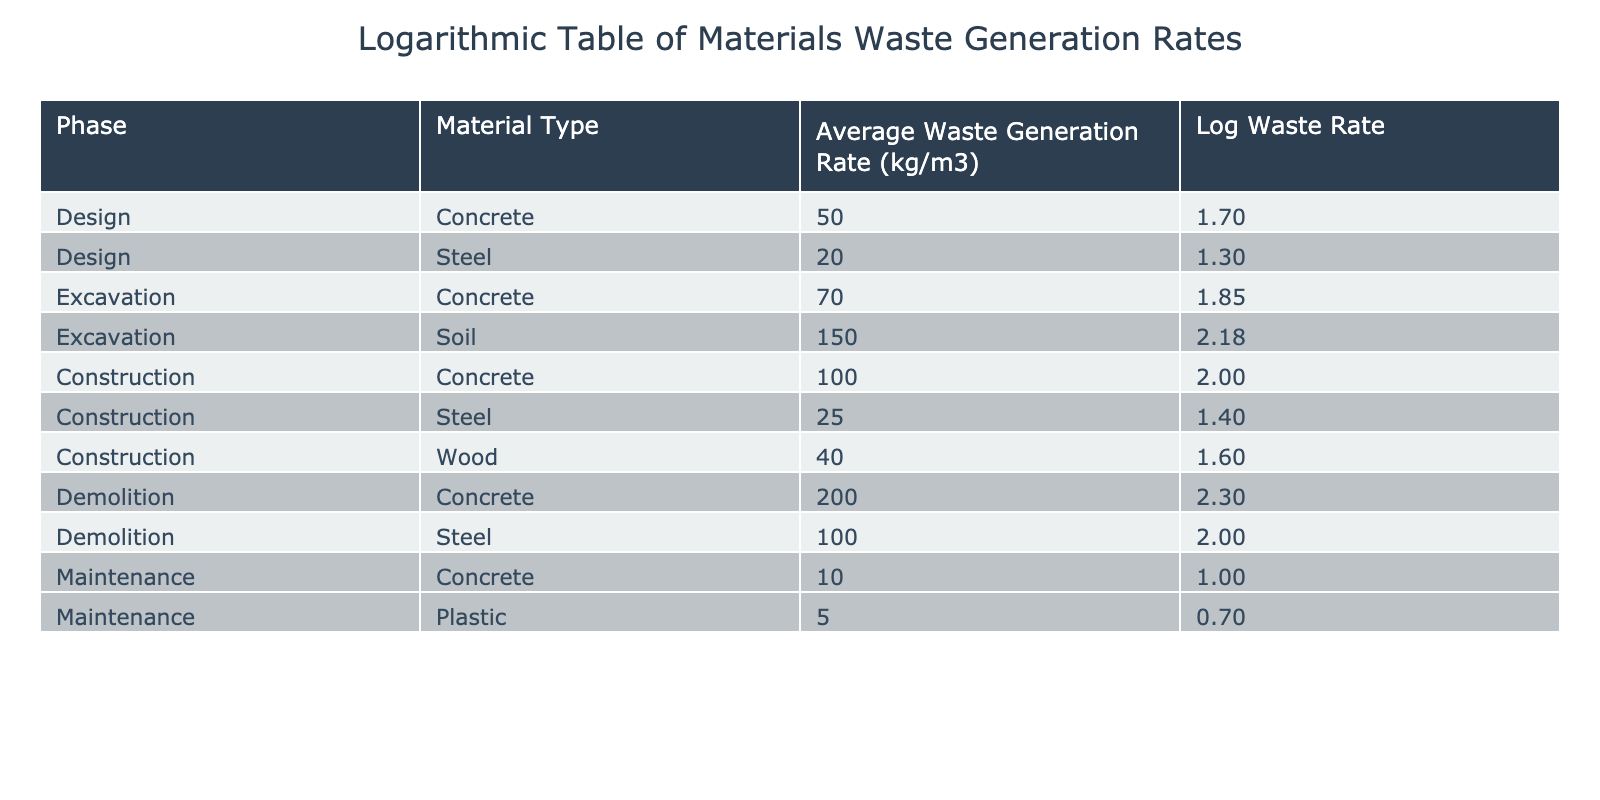What is the average waste generation rate for concrete during the construction phase? The table shows that the average waste generation rate for concrete during the construction phase is 100 kg/m3. This specific value can be directly found in the row corresponding to construction and concrete.
Answer: 100 kg/m3 What is the log waste generation rate for steel during the design phase? According to the table, the average waste generation rate for steel during the design phase is 20 kg/m3. Applying the logarithmic transformation gives log(20) ≈ 1.30. This value is calculated from the corresponding entry in the table.
Answer: 1.30 Which phase has the highest average waste generation rate for soil? From the table, the only entry for soil is during the excavation phase with a waste generation rate of 150 kg/m3, which is the highest since it has no other entries in other phases.
Answer: Excavation Is the average waste generation rate for plastic during maintenance higher than that for steel during construction? The average waste generation rate for plastic during maintenance is 5 kg/m3, while for steel during construction it is 25 kg/m3. Since 5 is less than 25, the statement is false. This can be confirmed by comparing the two specific entries in the table.
Answer: No What is the total average waste generation rate for materials during the demolition phase? The demolition phase has two materials listed: concrete (200 kg/m3) and steel (100 kg/m3). Summing these gives: 200 + 100 = 300 kg/m3. This is calculated by adding the waste generation rates for both materials listed under the demolition phase.
Answer: 300 kg/m3 During which phase is the average waste generation rate for concrete the lowest? The data shows that the average waste generation rates for concrete are as follows: 50 kg/m3 during design, 70 kg/m3 during excavation, 100 kg/m3 during construction, and 200 kg/m3 during demolition. The lowest rate is 50 kg/m3 which occurs during the design phase.
Answer: Design What is the log waste generation rate for wood during the construction phase? The average waste generation rate for wood during construction is 40 kg/m3. The logarithmic value log(40) ≈ 1.60 is calculated based on this figure and found directly in the specific wood entry for the construction phase.
Answer: 1.60 Is the average waste generation rate for materials during the maintenance phase lower than 10 kg/m3? The maintenance phase shows concrete at 10 kg/m3 and plastic at 5 kg/m3. The highest rate in maintenance is 10 kg/m3 which means it is not lower than 10. Therefore, the statement is false.
Answer: No 